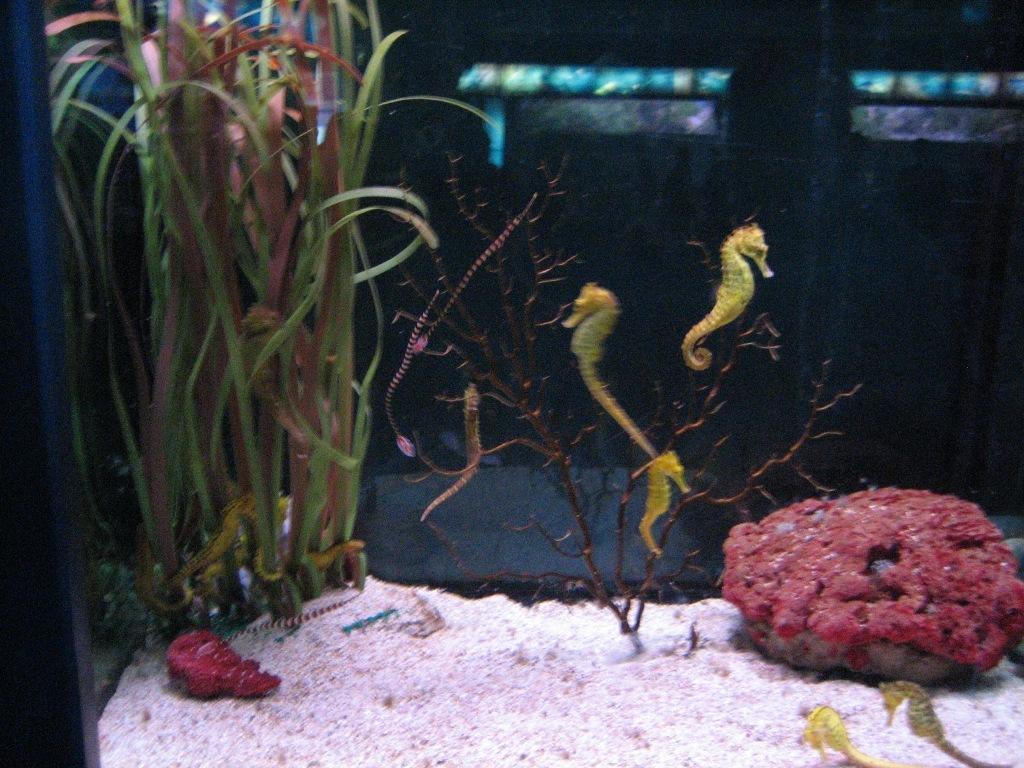Describe this image in one or two sentences. This picture consists of plants and red color flowers visible. 